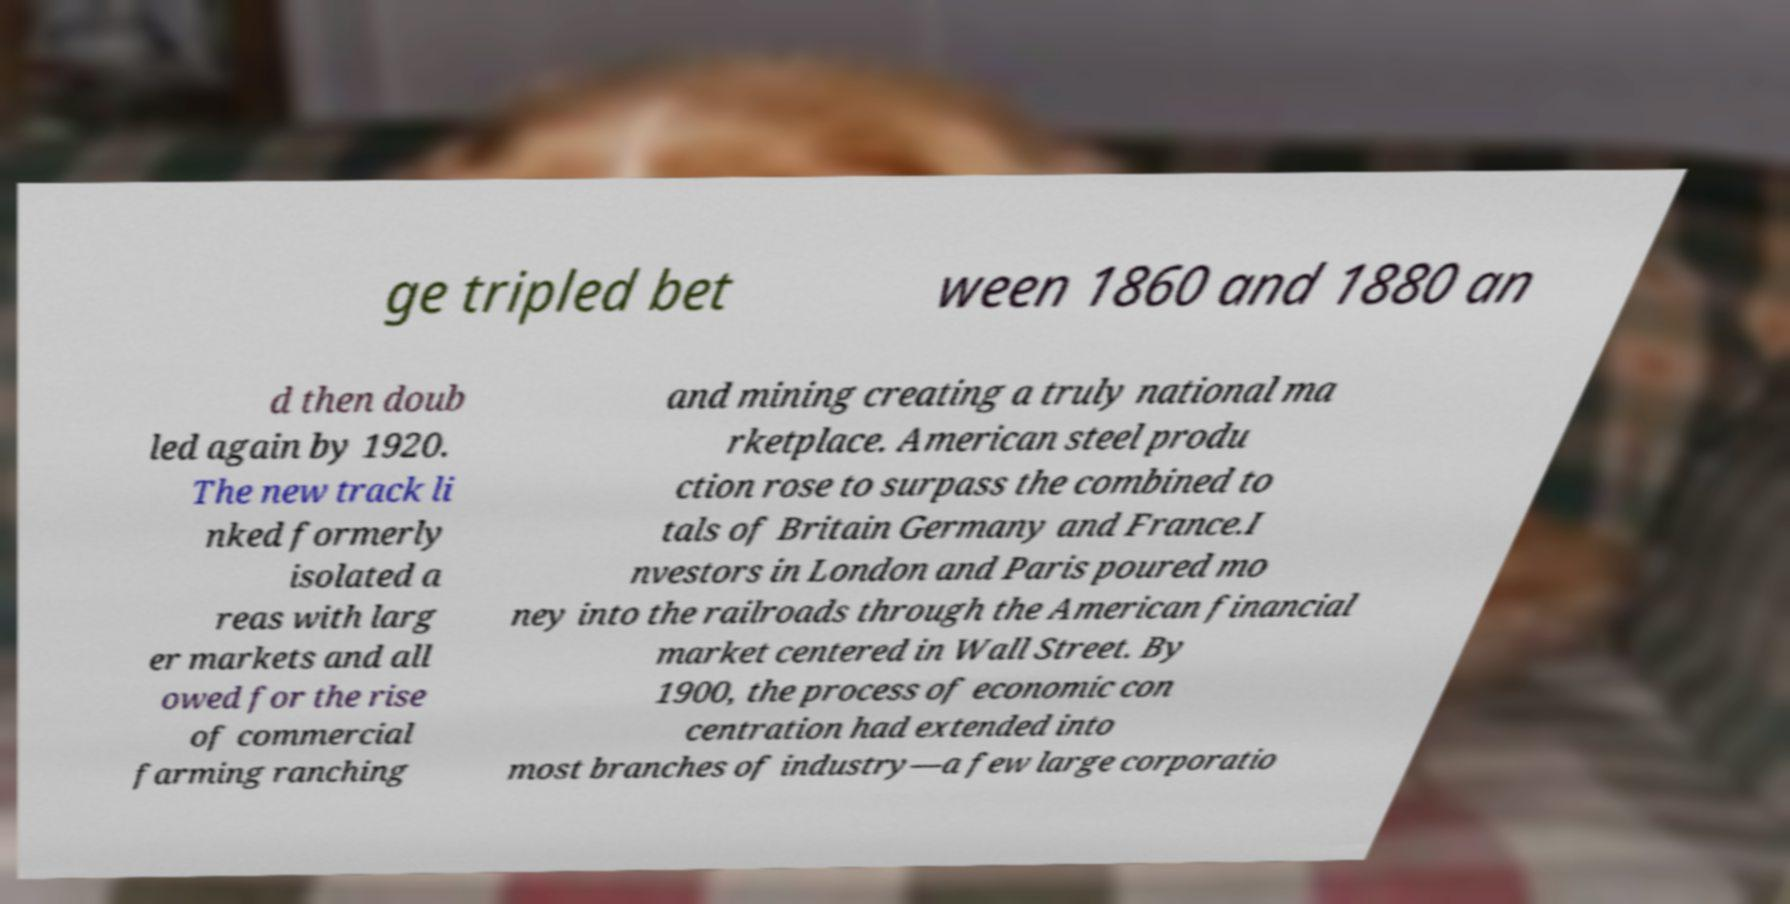There's text embedded in this image that I need extracted. Can you transcribe it verbatim? ge tripled bet ween 1860 and 1880 an d then doub led again by 1920. The new track li nked formerly isolated a reas with larg er markets and all owed for the rise of commercial farming ranching and mining creating a truly national ma rketplace. American steel produ ction rose to surpass the combined to tals of Britain Germany and France.I nvestors in London and Paris poured mo ney into the railroads through the American financial market centered in Wall Street. By 1900, the process of economic con centration had extended into most branches of industry—a few large corporatio 